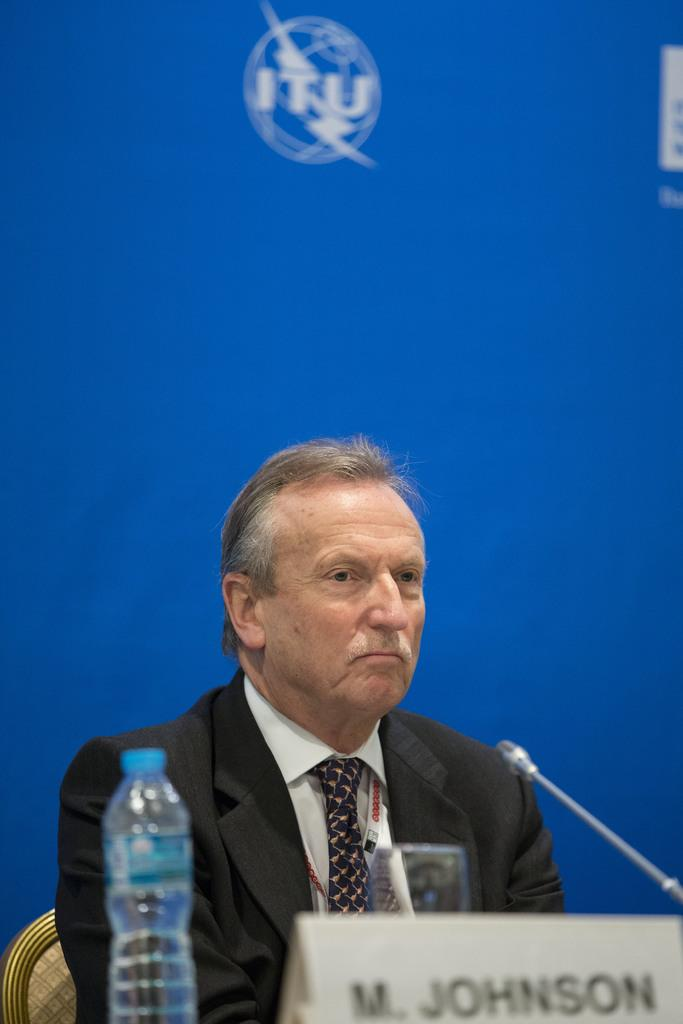What is the man in the image doing? The man is sitting on a chair in the image. What objects are in front of the man? There is a water bottle, a name plate, and a mic in front of the man. What color is the banner in the background of the image? The banner in the background of the image is blue. What statement does the doctor make in the image? There is no doctor present in the image, and therefore no statement can be attributed to a doctor. How many arms does the man have in the image? The image does not show the man's arms, so it cannot be determined how many arms he has. 